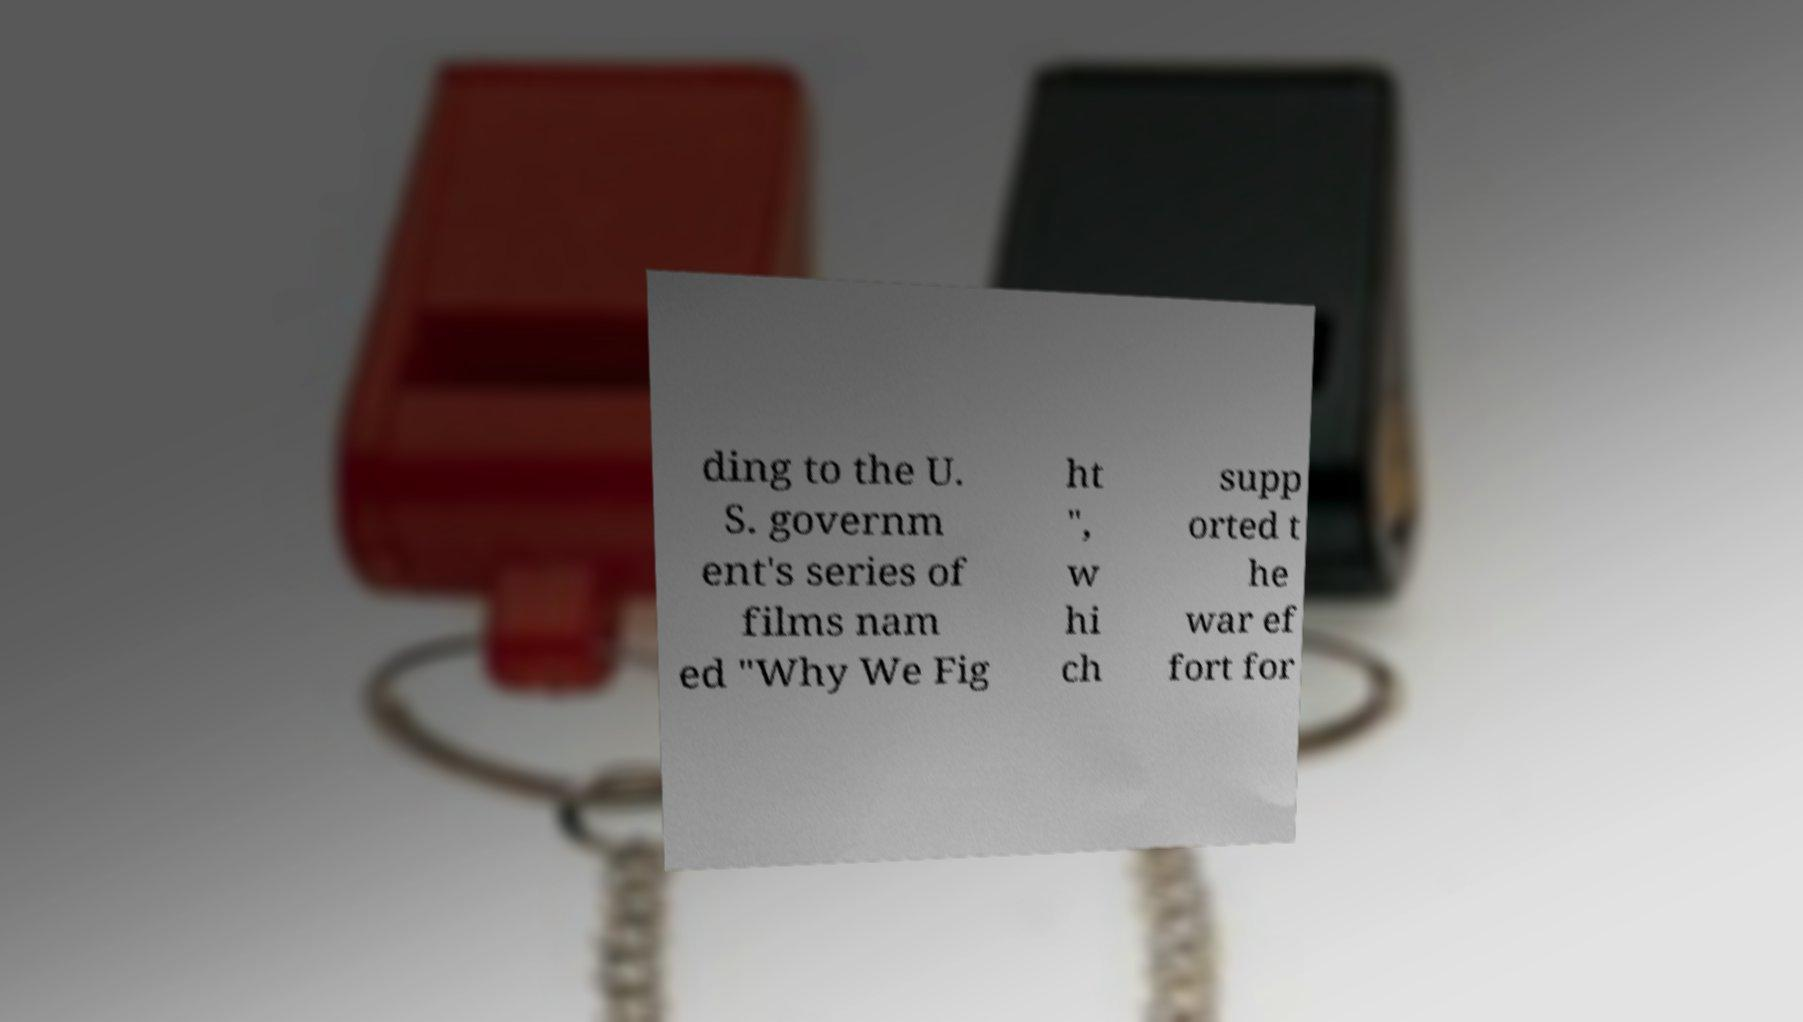Could you assist in decoding the text presented in this image and type it out clearly? ding to the U. S. governm ent's series of films nam ed "Why We Fig ht ", w hi ch supp orted t he war ef fort for 